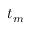<formula> <loc_0><loc_0><loc_500><loc_500>t _ { m }</formula> 